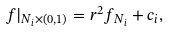Convert formula to latex. <formula><loc_0><loc_0><loc_500><loc_500>f | _ { N _ { i } \times ( 0 , 1 ) } = r ^ { 2 } f _ { N _ { i } } + c _ { i } ,</formula> 